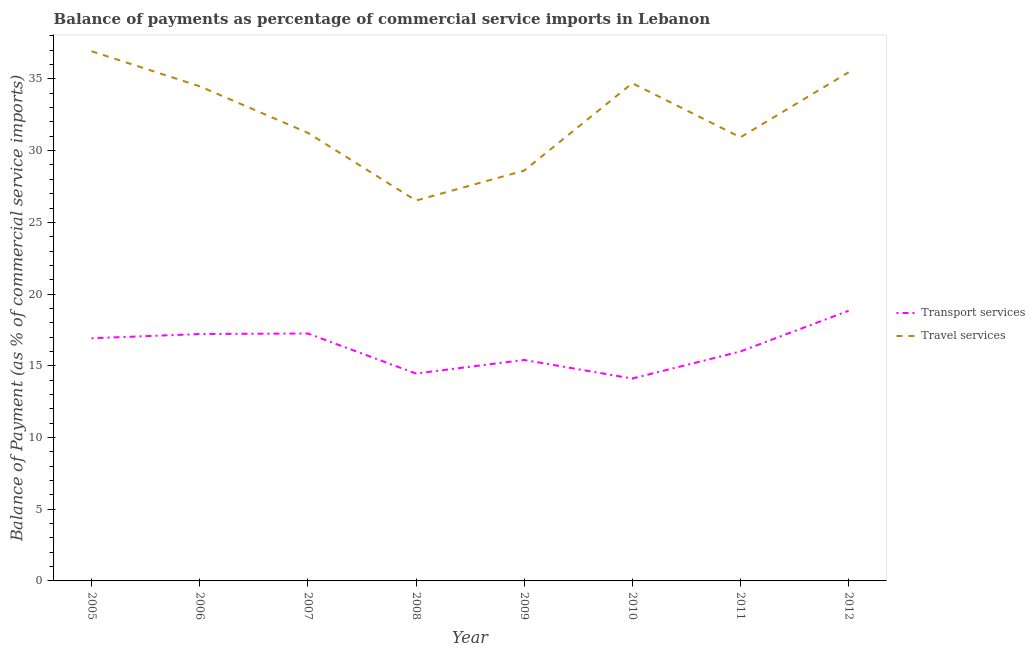How many different coloured lines are there?
Offer a terse response. 2. Does the line corresponding to balance of payments of transport services intersect with the line corresponding to balance of payments of travel services?
Provide a short and direct response. No. What is the balance of payments of transport services in 2005?
Your answer should be very brief. 16.92. Across all years, what is the maximum balance of payments of transport services?
Provide a short and direct response. 18.84. Across all years, what is the minimum balance of payments of transport services?
Ensure brevity in your answer.  14.11. In which year was the balance of payments of transport services maximum?
Make the answer very short. 2012. What is the total balance of payments of transport services in the graph?
Your answer should be very brief. 130.19. What is the difference between the balance of payments of transport services in 2010 and that in 2011?
Offer a terse response. -1.89. What is the difference between the balance of payments of transport services in 2010 and the balance of payments of travel services in 2008?
Your answer should be very brief. -12.41. What is the average balance of payments of travel services per year?
Offer a very short reply. 32.36. In the year 2006, what is the difference between the balance of payments of transport services and balance of payments of travel services?
Provide a short and direct response. -17.27. In how many years, is the balance of payments of transport services greater than 20 %?
Offer a terse response. 0. What is the ratio of the balance of payments of transport services in 2008 to that in 2010?
Keep it short and to the point. 1.02. Is the difference between the balance of payments of transport services in 2007 and 2012 greater than the difference between the balance of payments of travel services in 2007 and 2012?
Offer a very short reply. Yes. What is the difference between the highest and the second highest balance of payments of transport services?
Your answer should be compact. 1.59. What is the difference between the highest and the lowest balance of payments of transport services?
Give a very brief answer. 4.73. In how many years, is the balance of payments of transport services greater than the average balance of payments of transport services taken over all years?
Provide a succinct answer. 4. Is the sum of the balance of payments of travel services in 2005 and 2012 greater than the maximum balance of payments of transport services across all years?
Offer a very short reply. Yes. What is the difference between two consecutive major ticks on the Y-axis?
Make the answer very short. 5. Does the graph contain any zero values?
Ensure brevity in your answer.  No. Does the graph contain grids?
Your response must be concise. No. Where does the legend appear in the graph?
Your response must be concise. Center right. What is the title of the graph?
Give a very brief answer. Balance of payments as percentage of commercial service imports in Lebanon. Does "Primary school" appear as one of the legend labels in the graph?
Provide a short and direct response. No. What is the label or title of the Y-axis?
Keep it short and to the point. Balance of Payment (as % of commercial service imports). What is the Balance of Payment (as % of commercial service imports) of Transport services in 2005?
Your answer should be very brief. 16.92. What is the Balance of Payment (as % of commercial service imports) in Travel services in 2005?
Keep it short and to the point. 36.93. What is the Balance of Payment (as % of commercial service imports) of Transport services in 2006?
Make the answer very short. 17.21. What is the Balance of Payment (as % of commercial service imports) of Travel services in 2006?
Keep it short and to the point. 34.49. What is the Balance of Payment (as % of commercial service imports) of Transport services in 2007?
Offer a terse response. 17.25. What is the Balance of Payment (as % of commercial service imports) in Travel services in 2007?
Your answer should be very brief. 31.24. What is the Balance of Payment (as % of commercial service imports) of Transport services in 2008?
Your answer should be compact. 14.46. What is the Balance of Payment (as % of commercial service imports) in Travel services in 2008?
Provide a succinct answer. 26.52. What is the Balance of Payment (as % of commercial service imports) of Transport services in 2009?
Offer a very short reply. 15.41. What is the Balance of Payment (as % of commercial service imports) of Travel services in 2009?
Your response must be concise. 28.61. What is the Balance of Payment (as % of commercial service imports) in Transport services in 2010?
Provide a short and direct response. 14.11. What is the Balance of Payment (as % of commercial service imports) of Travel services in 2010?
Your answer should be very brief. 34.7. What is the Balance of Payment (as % of commercial service imports) of Transport services in 2011?
Ensure brevity in your answer.  16. What is the Balance of Payment (as % of commercial service imports) of Travel services in 2011?
Your answer should be compact. 30.93. What is the Balance of Payment (as % of commercial service imports) in Transport services in 2012?
Your answer should be compact. 18.84. What is the Balance of Payment (as % of commercial service imports) of Travel services in 2012?
Provide a succinct answer. 35.46. Across all years, what is the maximum Balance of Payment (as % of commercial service imports) of Transport services?
Keep it short and to the point. 18.84. Across all years, what is the maximum Balance of Payment (as % of commercial service imports) in Travel services?
Your answer should be very brief. 36.93. Across all years, what is the minimum Balance of Payment (as % of commercial service imports) of Transport services?
Make the answer very short. 14.11. Across all years, what is the minimum Balance of Payment (as % of commercial service imports) of Travel services?
Make the answer very short. 26.52. What is the total Balance of Payment (as % of commercial service imports) in Transport services in the graph?
Give a very brief answer. 130.19. What is the total Balance of Payment (as % of commercial service imports) in Travel services in the graph?
Make the answer very short. 258.88. What is the difference between the Balance of Payment (as % of commercial service imports) in Transport services in 2005 and that in 2006?
Keep it short and to the point. -0.3. What is the difference between the Balance of Payment (as % of commercial service imports) of Travel services in 2005 and that in 2006?
Your response must be concise. 2.44. What is the difference between the Balance of Payment (as % of commercial service imports) of Transport services in 2005 and that in 2007?
Keep it short and to the point. -0.33. What is the difference between the Balance of Payment (as % of commercial service imports) in Travel services in 2005 and that in 2007?
Make the answer very short. 5.69. What is the difference between the Balance of Payment (as % of commercial service imports) in Transport services in 2005 and that in 2008?
Provide a succinct answer. 2.46. What is the difference between the Balance of Payment (as % of commercial service imports) in Travel services in 2005 and that in 2008?
Your response must be concise. 10.41. What is the difference between the Balance of Payment (as % of commercial service imports) in Transport services in 2005 and that in 2009?
Ensure brevity in your answer.  1.51. What is the difference between the Balance of Payment (as % of commercial service imports) of Travel services in 2005 and that in 2009?
Provide a succinct answer. 8.32. What is the difference between the Balance of Payment (as % of commercial service imports) of Transport services in 2005 and that in 2010?
Provide a succinct answer. 2.81. What is the difference between the Balance of Payment (as % of commercial service imports) in Travel services in 2005 and that in 2010?
Your answer should be very brief. 2.23. What is the difference between the Balance of Payment (as % of commercial service imports) of Transport services in 2005 and that in 2011?
Offer a terse response. 0.92. What is the difference between the Balance of Payment (as % of commercial service imports) of Travel services in 2005 and that in 2011?
Offer a terse response. 6. What is the difference between the Balance of Payment (as % of commercial service imports) of Transport services in 2005 and that in 2012?
Your answer should be compact. -1.92. What is the difference between the Balance of Payment (as % of commercial service imports) in Travel services in 2005 and that in 2012?
Provide a short and direct response. 1.47. What is the difference between the Balance of Payment (as % of commercial service imports) of Transport services in 2006 and that in 2007?
Provide a short and direct response. -0.04. What is the difference between the Balance of Payment (as % of commercial service imports) of Travel services in 2006 and that in 2007?
Give a very brief answer. 3.25. What is the difference between the Balance of Payment (as % of commercial service imports) of Transport services in 2006 and that in 2008?
Offer a terse response. 2.75. What is the difference between the Balance of Payment (as % of commercial service imports) in Travel services in 2006 and that in 2008?
Provide a short and direct response. 7.97. What is the difference between the Balance of Payment (as % of commercial service imports) of Transport services in 2006 and that in 2009?
Give a very brief answer. 1.81. What is the difference between the Balance of Payment (as % of commercial service imports) of Travel services in 2006 and that in 2009?
Provide a short and direct response. 5.88. What is the difference between the Balance of Payment (as % of commercial service imports) of Transport services in 2006 and that in 2010?
Offer a very short reply. 3.1. What is the difference between the Balance of Payment (as % of commercial service imports) in Travel services in 2006 and that in 2010?
Provide a succinct answer. -0.21. What is the difference between the Balance of Payment (as % of commercial service imports) in Transport services in 2006 and that in 2011?
Provide a short and direct response. 1.21. What is the difference between the Balance of Payment (as % of commercial service imports) of Travel services in 2006 and that in 2011?
Offer a very short reply. 3.56. What is the difference between the Balance of Payment (as % of commercial service imports) in Transport services in 2006 and that in 2012?
Ensure brevity in your answer.  -1.62. What is the difference between the Balance of Payment (as % of commercial service imports) in Travel services in 2006 and that in 2012?
Provide a succinct answer. -0.98. What is the difference between the Balance of Payment (as % of commercial service imports) of Transport services in 2007 and that in 2008?
Your answer should be compact. 2.79. What is the difference between the Balance of Payment (as % of commercial service imports) in Travel services in 2007 and that in 2008?
Your answer should be very brief. 4.72. What is the difference between the Balance of Payment (as % of commercial service imports) in Transport services in 2007 and that in 2009?
Provide a succinct answer. 1.84. What is the difference between the Balance of Payment (as % of commercial service imports) of Travel services in 2007 and that in 2009?
Offer a very short reply. 2.63. What is the difference between the Balance of Payment (as % of commercial service imports) of Transport services in 2007 and that in 2010?
Provide a succinct answer. 3.14. What is the difference between the Balance of Payment (as % of commercial service imports) of Travel services in 2007 and that in 2010?
Make the answer very short. -3.46. What is the difference between the Balance of Payment (as % of commercial service imports) in Transport services in 2007 and that in 2011?
Keep it short and to the point. 1.25. What is the difference between the Balance of Payment (as % of commercial service imports) of Travel services in 2007 and that in 2011?
Your answer should be very brief. 0.31. What is the difference between the Balance of Payment (as % of commercial service imports) in Transport services in 2007 and that in 2012?
Your answer should be compact. -1.59. What is the difference between the Balance of Payment (as % of commercial service imports) of Travel services in 2007 and that in 2012?
Make the answer very short. -4.22. What is the difference between the Balance of Payment (as % of commercial service imports) of Transport services in 2008 and that in 2009?
Offer a very short reply. -0.95. What is the difference between the Balance of Payment (as % of commercial service imports) in Travel services in 2008 and that in 2009?
Your answer should be very brief. -2.09. What is the difference between the Balance of Payment (as % of commercial service imports) in Transport services in 2008 and that in 2010?
Provide a succinct answer. 0.35. What is the difference between the Balance of Payment (as % of commercial service imports) in Travel services in 2008 and that in 2010?
Offer a very short reply. -8.18. What is the difference between the Balance of Payment (as % of commercial service imports) of Transport services in 2008 and that in 2011?
Make the answer very short. -1.54. What is the difference between the Balance of Payment (as % of commercial service imports) in Travel services in 2008 and that in 2011?
Your response must be concise. -4.41. What is the difference between the Balance of Payment (as % of commercial service imports) in Transport services in 2008 and that in 2012?
Ensure brevity in your answer.  -4.38. What is the difference between the Balance of Payment (as % of commercial service imports) in Travel services in 2008 and that in 2012?
Offer a very short reply. -8.94. What is the difference between the Balance of Payment (as % of commercial service imports) of Transport services in 2009 and that in 2010?
Offer a terse response. 1.3. What is the difference between the Balance of Payment (as % of commercial service imports) of Travel services in 2009 and that in 2010?
Make the answer very short. -6.09. What is the difference between the Balance of Payment (as % of commercial service imports) in Transport services in 2009 and that in 2011?
Provide a short and direct response. -0.59. What is the difference between the Balance of Payment (as % of commercial service imports) in Travel services in 2009 and that in 2011?
Provide a succinct answer. -2.32. What is the difference between the Balance of Payment (as % of commercial service imports) in Transport services in 2009 and that in 2012?
Offer a very short reply. -3.43. What is the difference between the Balance of Payment (as % of commercial service imports) of Travel services in 2009 and that in 2012?
Offer a terse response. -6.86. What is the difference between the Balance of Payment (as % of commercial service imports) of Transport services in 2010 and that in 2011?
Give a very brief answer. -1.89. What is the difference between the Balance of Payment (as % of commercial service imports) of Travel services in 2010 and that in 2011?
Provide a succinct answer. 3.77. What is the difference between the Balance of Payment (as % of commercial service imports) in Transport services in 2010 and that in 2012?
Offer a very short reply. -4.73. What is the difference between the Balance of Payment (as % of commercial service imports) of Travel services in 2010 and that in 2012?
Provide a short and direct response. -0.76. What is the difference between the Balance of Payment (as % of commercial service imports) in Transport services in 2011 and that in 2012?
Offer a very short reply. -2.84. What is the difference between the Balance of Payment (as % of commercial service imports) in Travel services in 2011 and that in 2012?
Ensure brevity in your answer.  -4.53. What is the difference between the Balance of Payment (as % of commercial service imports) in Transport services in 2005 and the Balance of Payment (as % of commercial service imports) in Travel services in 2006?
Keep it short and to the point. -17.57. What is the difference between the Balance of Payment (as % of commercial service imports) in Transport services in 2005 and the Balance of Payment (as % of commercial service imports) in Travel services in 2007?
Offer a very short reply. -14.32. What is the difference between the Balance of Payment (as % of commercial service imports) of Transport services in 2005 and the Balance of Payment (as % of commercial service imports) of Travel services in 2008?
Offer a very short reply. -9.6. What is the difference between the Balance of Payment (as % of commercial service imports) in Transport services in 2005 and the Balance of Payment (as % of commercial service imports) in Travel services in 2009?
Your answer should be compact. -11.69. What is the difference between the Balance of Payment (as % of commercial service imports) in Transport services in 2005 and the Balance of Payment (as % of commercial service imports) in Travel services in 2010?
Provide a short and direct response. -17.78. What is the difference between the Balance of Payment (as % of commercial service imports) of Transport services in 2005 and the Balance of Payment (as % of commercial service imports) of Travel services in 2011?
Keep it short and to the point. -14.01. What is the difference between the Balance of Payment (as % of commercial service imports) of Transport services in 2005 and the Balance of Payment (as % of commercial service imports) of Travel services in 2012?
Your answer should be very brief. -18.55. What is the difference between the Balance of Payment (as % of commercial service imports) in Transport services in 2006 and the Balance of Payment (as % of commercial service imports) in Travel services in 2007?
Keep it short and to the point. -14.03. What is the difference between the Balance of Payment (as % of commercial service imports) in Transport services in 2006 and the Balance of Payment (as % of commercial service imports) in Travel services in 2008?
Your answer should be very brief. -9.31. What is the difference between the Balance of Payment (as % of commercial service imports) in Transport services in 2006 and the Balance of Payment (as % of commercial service imports) in Travel services in 2009?
Provide a succinct answer. -11.39. What is the difference between the Balance of Payment (as % of commercial service imports) in Transport services in 2006 and the Balance of Payment (as % of commercial service imports) in Travel services in 2010?
Offer a terse response. -17.49. What is the difference between the Balance of Payment (as % of commercial service imports) of Transport services in 2006 and the Balance of Payment (as % of commercial service imports) of Travel services in 2011?
Offer a terse response. -13.72. What is the difference between the Balance of Payment (as % of commercial service imports) of Transport services in 2006 and the Balance of Payment (as % of commercial service imports) of Travel services in 2012?
Provide a succinct answer. -18.25. What is the difference between the Balance of Payment (as % of commercial service imports) in Transport services in 2007 and the Balance of Payment (as % of commercial service imports) in Travel services in 2008?
Your response must be concise. -9.27. What is the difference between the Balance of Payment (as % of commercial service imports) of Transport services in 2007 and the Balance of Payment (as % of commercial service imports) of Travel services in 2009?
Your answer should be very brief. -11.36. What is the difference between the Balance of Payment (as % of commercial service imports) of Transport services in 2007 and the Balance of Payment (as % of commercial service imports) of Travel services in 2010?
Your answer should be very brief. -17.45. What is the difference between the Balance of Payment (as % of commercial service imports) in Transport services in 2007 and the Balance of Payment (as % of commercial service imports) in Travel services in 2011?
Give a very brief answer. -13.68. What is the difference between the Balance of Payment (as % of commercial service imports) of Transport services in 2007 and the Balance of Payment (as % of commercial service imports) of Travel services in 2012?
Make the answer very short. -18.21. What is the difference between the Balance of Payment (as % of commercial service imports) of Transport services in 2008 and the Balance of Payment (as % of commercial service imports) of Travel services in 2009?
Provide a short and direct response. -14.15. What is the difference between the Balance of Payment (as % of commercial service imports) in Transport services in 2008 and the Balance of Payment (as % of commercial service imports) in Travel services in 2010?
Give a very brief answer. -20.24. What is the difference between the Balance of Payment (as % of commercial service imports) in Transport services in 2008 and the Balance of Payment (as % of commercial service imports) in Travel services in 2011?
Keep it short and to the point. -16.47. What is the difference between the Balance of Payment (as % of commercial service imports) in Transport services in 2008 and the Balance of Payment (as % of commercial service imports) in Travel services in 2012?
Make the answer very short. -21. What is the difference between the Balance of Payment (as % of commercial service imports) of Transport services in 2009 and the Balance of Payment (as % of commercial service imports) of Travel services in 2010?
Provide a short and direct response. -19.29. What is the difference between the Balance of Payment (as % of commercial service imports) in Transport services in 2009 and the Balance of Payment (as % of commercial service imports) in Travel services in 2011?
Your answer should be compact. -15.53. What is the difference between the Balance of Payment (as % of commercial service imports) of Transport services in 2009 and the Balance of Payment (as % of commercial service imports) of Travel services in 2012?
Provide a succinct answer. -20.06. What is the difference between the Balance of Payment (as % of commercial service imports) in Transport services in 2010 and the Balance of Payment (as % of commercial service imports) in Travel services in 2011?
Your answer should be very brief. -16.82. What is the difference between the Balance of Payment (as % of commercial service imports) of Transport services in 2010 and the Balance of Payment (as % of commercial service imports) of Travel services in 2012?
Ensure brevity in your answer.  -21.35. What is the difference between the Balance of Payment (as % of commercial service imports) in Transport services in 2011 and the Balance of Payment (as % of commercial service imports) in Travel services in 2012?
Offer a terse response. -19.46. What is the average Balance of Payment (as % of commercial service imports) of Transport services per year?
Your response must be concise. 16.27. What is the average Balance of Payment (as % of commercial service imports) of Travel services per year?
Offer a terse response. 32.36. In the year 2005, what is the difference between the Balance of Payment (as % of commercial service imports) in Transport services and Balance of Payment (as % of commercial service imports) in Travel services?
Your answer should be compact. -20.01. In the year 2006, what is the difference between the Balance of Payment (as % of commercial service imports) in Transport services and Balance of Payment (as % of commercial service imports) in Travel services?
Provide a succinct answer. -17.27. In the year 2007, what is the difference between the Balance of Payment (as % of commercial service imports) in Transport services and Balance of Payment (as % of commercial service imports) in Travel services?
Your answer should be very brief. -13.99. In the year 2008, what is the difference between the Balance of Payment (as % of commercial service imports) of Transport services and Balance of Payment (as % of commercial service imports) of Travel services?
Offer a very short reply. -12.06. In the year 2009, what is the difference between the Balance of Payment (as % of commercial service imports) of Transport services and Balance of Payment (as % of commercial service imports) of Travel services?
Provide a succinct answer. -13.2. In the year 2010, what is the difference between the Balance of Payment (as % of commercial service imports) of Transport services and Balance of Payment (as % of commercial service imports) of Travel services?
Provide a succinct answer. -20.59. In the year 2011, what is the difference between the Balance of Payment (as % of commercial service imports) in Transport services and Balance of Payment (as % of commercial service imports) in Travel services?
Make the answer very short. -14.93. In the year 2012, what is the difference between the Balance of Payment (as % of commercial service imports) of Transport services and Balance of Payment (as % of commercial service imports) of Travel services?
Make the answer very short. -16.63. What is the ratio of the Balance of Payment (as % of commercial service imports) of Transport services in 2005 to that in 2006?
Your answer should be very brief. 0.98. What is the ratio of the Balance of Payment (as % of commercial service imports) of Travel services in 2005 to that in 2006?
Provide a succinct answer. 1.07. What is the ratio of the Balance of Payment (as % of commercial service imports) of Transport services in 2005 to that in 2007?
Provide a short and direct response. 0.98. What is the ratio of the Balance of Payment (as % of commercial service imports) in Travel services in 2005 to that in 2007?
Keep it short and to the point. 1.18. What is the ratio of the Balance of Payment (as % of commercial service imports) of Transport services in 2005 to that in 2008?
Keep it short and to the point. 1.17. What is the ratio of the Balance of Payment (as % of commercial service imports) of Travel services in 2005 to that in 2008?
Ensure brevity in your answer.  1.39. What is the ratio of the Balance of Payment (as % of commercial service imports) of Transport services in 2005 to that in 2009?
Your response must be concise. 1.1. What is the ratio of the Balance of Payment (as % of commercial service imports) in Travel services in 2005 to that in 2009?
Provide a short and direct response. 1.29. What is the ratio of the Balance of Payment (as % of commercial service imports) of Transport services in 2005 to that in 2010?
Offer a terse response. 1.2. What is the ratio of the Balance of Payment (as % of commercial service imports) of Travel services in 2005 to that in 2010?
Give a very brief answer. 1.06. What is the ratio of the Balance of Payment (as % of commercial service imports) of Transport services in 2005 to that in 2011?
Your answer should be compact. 1.06. What is the ratio of the Balance of Payment (as % of commercial service imports) of Travel services in 2005 to that in 2011?
Ensure brevity in your answer.  1.19. What is the ratio of the Balance of Payment (as % of commercial service imports) of Transport services in 2005 to that in 2012?
Offer a very short reply. 0.9. What is the ratio of the Balance of Payment (as % of commercial service imports) of Travel services in 2005 to that in 2012?
Your response must be concise. 1.04. What is the ratio of the Balance of Payment (as % of commercial service imports) in Travel services in 2006 to that in 2007?
Ensure brevity in your answer.  1.1. What is the ratio of the Balance of Payment (as % of commercial service imports) of Transport services in 2006 to that in 2008?
Provide a succinct answer. 1.19. What is the ratio of the Balance of Payment (as % of commercial service imports) of Travel services in 2006 to that in 2008?
Ensure brevity in your answer.  1.3. What is the ratio of the Balance of Payment (as % of commercial service imports) of Transport services in 2006 to that in 2009?
Offer a very short reply. 1.12. What is the ratio of the Balance of Payment (as % of commercial service imports) of Travel services in 2006 to that in 2009?
Provide a short and direct response. 1.21. What is the ratio of the Balance of Payment (as % of commercial service imports) in Transport services in 2006 to that in 2010?
Your answer should be compact. 1.22. What is the ratio of the Balance of Payment (as % of commercial service imports) of Travel services in 2006 to that in 2010?
Provide a succinct answer. 0.99. What is the ratio of the Balance of Payment (as % of commercial service imports) of Transport services in 2006 to that in 2011?
Give a very brief answer. 1.08. What is the ratio of the Balance of Payment (as % of commercial service imports) of Travel services in 2006 to that in 2011?
Give a very brief answer. 1.11. What is the ratio of the Balance of Payment (as % of commercial service imports) in Transport services in 2006 to that in 2012?
Give a very brief answer. 0.91. What is the ratio of the Balance of Payment (as % of commercial service imports) in Travel services in 2006 to that in 2012?
Offer a terse response. 0.97. What is the ratio of the Balance of Payment (as % of commercial service imports) of Transport services in 2007 to that in 2008?
Provide a short and direct response. 1.19. What is the ratio of the Balance of Payment (as % of commercial service imports) in Travel services in 2007 to that in 2008?
Make the answer very short. 1.18. What is the ratio of the Balance of Payment (as % of commercial service imports) of Transport services in 2007 to that in 2009?
Offer a terse response. 1.12. What is the ratio of the Balance of Payment (as % of commercial service imports) of Travel services in 2007 to that in 2009?
Your answer should be compact. 1.09. What is the ratio of the Balance of Payment (as % of commercial service imports) in Transport services in 2007 to that in 2010?
Your answer should be compact. 1.22. What is the ratio of the Balance of Payment (as % of commercial service imports) of Travel services in 2007 to that in 2010?
Make the answer very short. 0.9. What is the ratio of the Balance of Payment (as % of commercial service imports) of Transport services in 2007 to that in 2011?
Your response must be concise. 1.08. What is the ratio of the Balance of Payment (as % of commercial service imports) in Travel services in 2007 to that in 2011?
Your answer should be compact. 1.01. What is the ratio of the Balance of Payment (as % of commercial service imports) of Transport services in 2007 to that in 2012?
Offer a very short reply. 0.92. What is the ratio of the Balance of Payment (as % of commercial service imports) in Travel services in 2007 to that in 2012?
Offer a terse response. 0.88. What is the ratio of the Balance of Payment (as % of commercial service imports) of Transport services in 2008 to that in 2009?
Ensure brevity in your answer.  0.94. What is the ratio of the Balance of Payment (as % of commercial service imports) in Travel services in 2008 to that in 2009?
Offer a terse response. 0.93. What is the ratio of the Balance of Payment (as % of commercial service imports) of Transport services in 2008 to that in 2010?
Give a very brief answer. 1.02. What is the ratio of the Balance of Payment (as % of commercial service imports) in Travel services in 2008 to that in 2010?
Your answer should be compact. 0.76. What is the ratio of the Balance of Payment (as % of commercial service imports) of Transport services in 2008 to that in 2011?
Your answer should be very brief. 0.9. What is the ratio of the Balance of Payment (as % of commercial service imports) in Travel services in 2008 to that in 2011?
Offer a very short reply. 0.86. What is the ratio of the Balance of Payment (as % of commercial service imports) of Transport services in 2008 to that in 2012?
Offer a terse response. 0.77. What is the ratio of the Balance of Payment (as % of commercial service imports) in Travel services in 2008 to that in 2012?
Offer a very short reply. 0.75. What is the ratio of the Balance of Payment (as % of commercial service imports) of Transport services in 2009 to that in 2010?
Ensure brevity in your answer.  1.09. What is the ratio of the Balance of Payment (as % of commercial service imports) in Travel services in 2009 to that in 2010?
Your answer should be very brief. 0.82. What is the ratio of the Balance of Payment (as % of commercial service imports) of Transport services in 2009 to that in 2011?
Give a very brief answer. 0.96. What is the ratio of the Balance of Payment (as % of commercial service imports) in Travel services in 2009 to that in 2011?
Provide a succinct answer. 0.92. What is the ratio of the Balance of Payment (as % of commercial service imports) in Transport services in 2009 to that in 2012?
Offer a very short reply. 0.82. What is the ratio of the Balance of Payment (as % of commercial service imports) in Travel services in 2009 to that in 2012?
Provide a succinct answer. 0.81. What is the ratio of the Balance of Payment (as % of commercial service imports) of Transport services in 2010 to that in 2011?
Your response must be concise. 0.88. What is the ratio of the Balance of Payment (as % of commercial service imports) of Travel services in 2010 to that in 2011?
Your response must be concise. 1.12. What is the ratio of the Balance of Payment (as % of commercial service imports) of Transport services in 2010 to that in 2012?
Give a very brief answer. 0.75. What is the ratio of the Balance of Payment (as % of commercial service imports) of Travel services in 2010 to that in 2012?
Offer a terse response. 0.98. What is the ratio of the Balance of Payment (as % of commercial service imports) of Transport services in 2011 to that in 2012?
Keep it short and to the point. 0.85. What is the ratio of the Balance of Payment (as % of commercial service imports) in Travel services in 2011 to that in 2012?
Offer a very short reply. 0.87. What is the difference between the highest and the second highest Balance of Payment (as % of commercial service imports) of Transport services?
Give a very brief answer. 1.59. What is the difference between the highest and the second highest Balance of Payment (as % of commercial service imports) of Travel services?
Make the answer very short. 1.47. What is the difference between the highest and the lowest Balance of Payment (as % of commercial service imports) in Transport services?
Your answer should be compact. 4.73. What is the difference between the highest and the lowest Balance of Payment (as % of commercial service imports) of Travel services?
Your response must be concise. 10.41. 